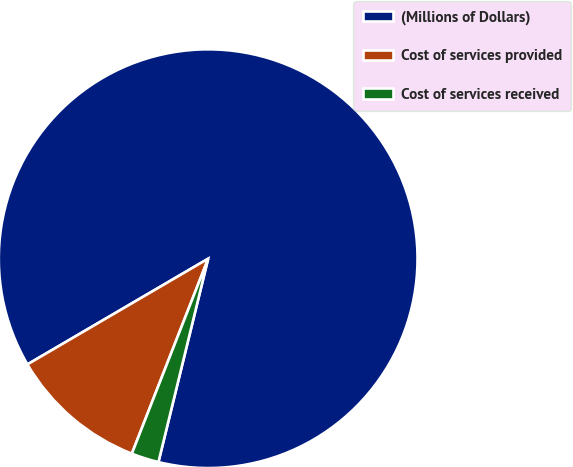Convert chart. <chart><loc_0><loc_0><loc_500><loc_500><pie_chart><fcel>(Millions of Dollars)<fcel>Cost of services provided<fcel>Cost of services received<nl><fcel>87.24%<fcel>10.64%<fcel>2.12%<nl></chart> 